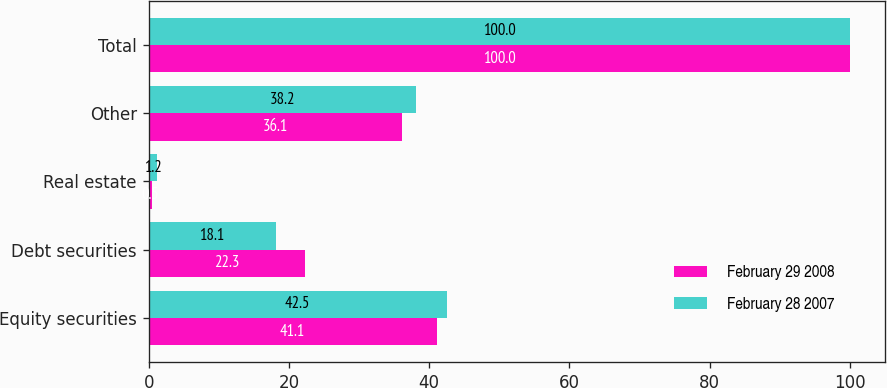Convert chart. <chart><loc_0><loc_0><loc_500><loc_500><stacked_bar_chart><ecel><fcel>Equity securities<fcel>Debt securities<fcel>Real estate<fcel>Other<fcel>Total<nl><fcel>February 29 2008<fcel>41.1<fcel>22.3<fcel>0.5<fcel>36.1<fcel>100<nl><fcel>February 28 2007<fcel>42.5<fcel>18.1<fcel>1.2<fcel>38.2<fcel>100<nl></chart> 